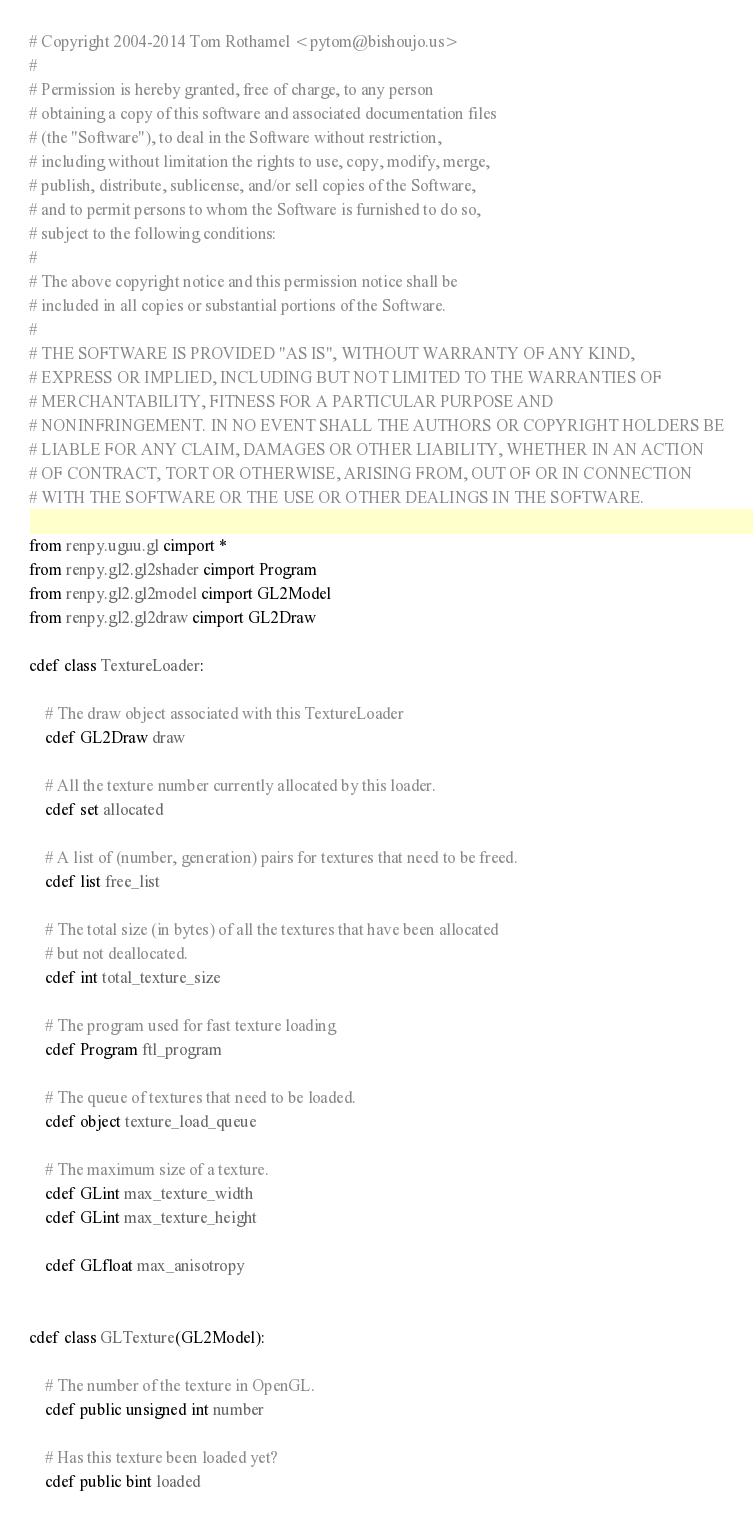Convert code to text. <code><loc_0><loc_0><loc_500><loc_500><_Cython_># Copyright 2004-2014 Tom Rothamel <pytom@bishoujo.us>
#
# Permission is hereby granted, free of charge, to any person
# obtaining a copy of this software and associated documentation files
# (the "Software"), to deal in the Software without restriction,
# including without limitation the rights to use, copy, modify, merge,
# publish, distribute, sublicense, and/or sell copies of the Software,
# and to permit persons to whom the Software is furnished to do so,
# subject to the following conditions:
#
# The above copyright notice and this permission notice shall be
# included in all copies or substantial portions of the Software.
#
# THE SOFTWARE IS PROVIDED "AS IS", WITHOUT WARRANTY OF ANY KIND,
# EXPRESS OR IMPLIED, INCLUDING BUT NOT LIMITED TO THE WARRANTIES OF
# MERCHANTABILITY, FITNESS FOR A PARTICULAR PURPOSE AND
# NONINFRINGEMENT. IN NO EVENT SHALL THE AUTHORS OR COPYRIGHT HOLDERS BE
# LIABLE FOR ANY CLAIM, DAMAGES OR OTHER LIABILITY, WHETHER IN AN ACTION
# OF CONTRACT, TORT OR OTHERWISE, ARISING FROM, OUT OF OR IN CONNECTION
# WITH THE SOFTWARE OR THE USE OR OTHER DEALINGS IN THE SOFTWARE.

from renpy.uguu.gl cimport *
from renpy.gl2.gl2shader cimport Program
from renpy.gl2.gl2model cimport GL2Model
from renpy.gl2.gl2draw cimport GL2Draw

cdef class TextureLoader:

    # The draw object associated with this TextureLoader
    cdef GL2Draw draw

    # All the texture number currently allocated by this loader.
    cdef set allocated

    # A list of (number, generation) pairs for textures that need to be freed.
    cdef list free_list

    # The total size (in bytes) of all the textures that have been allocated
    # but not deallocated.
    cdef int total_texture_size

    # The program used for fast texture loading
    cdef Program ftl_program

    # The queue of textures that need to be loaded.
    cdef object texture_load_queue

    # The maximum size of a texture.
    cdef GLint max_texture_width
    cdef GLint max_texture_height

    cdef GLfloat max_anisotropy


cdef class GLTexture(GL2Model):

    # The number of the texture in OpenGL.
    cdef public unsigned int number

    # Has this texture been loaded yet?
    cdef public bint loaded
</code> 